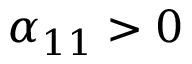Convert formula to latex. <formula><loc_0><loc_0><loc_500><loc_500>\alpha _ { 1 1 } > 0</formula> 